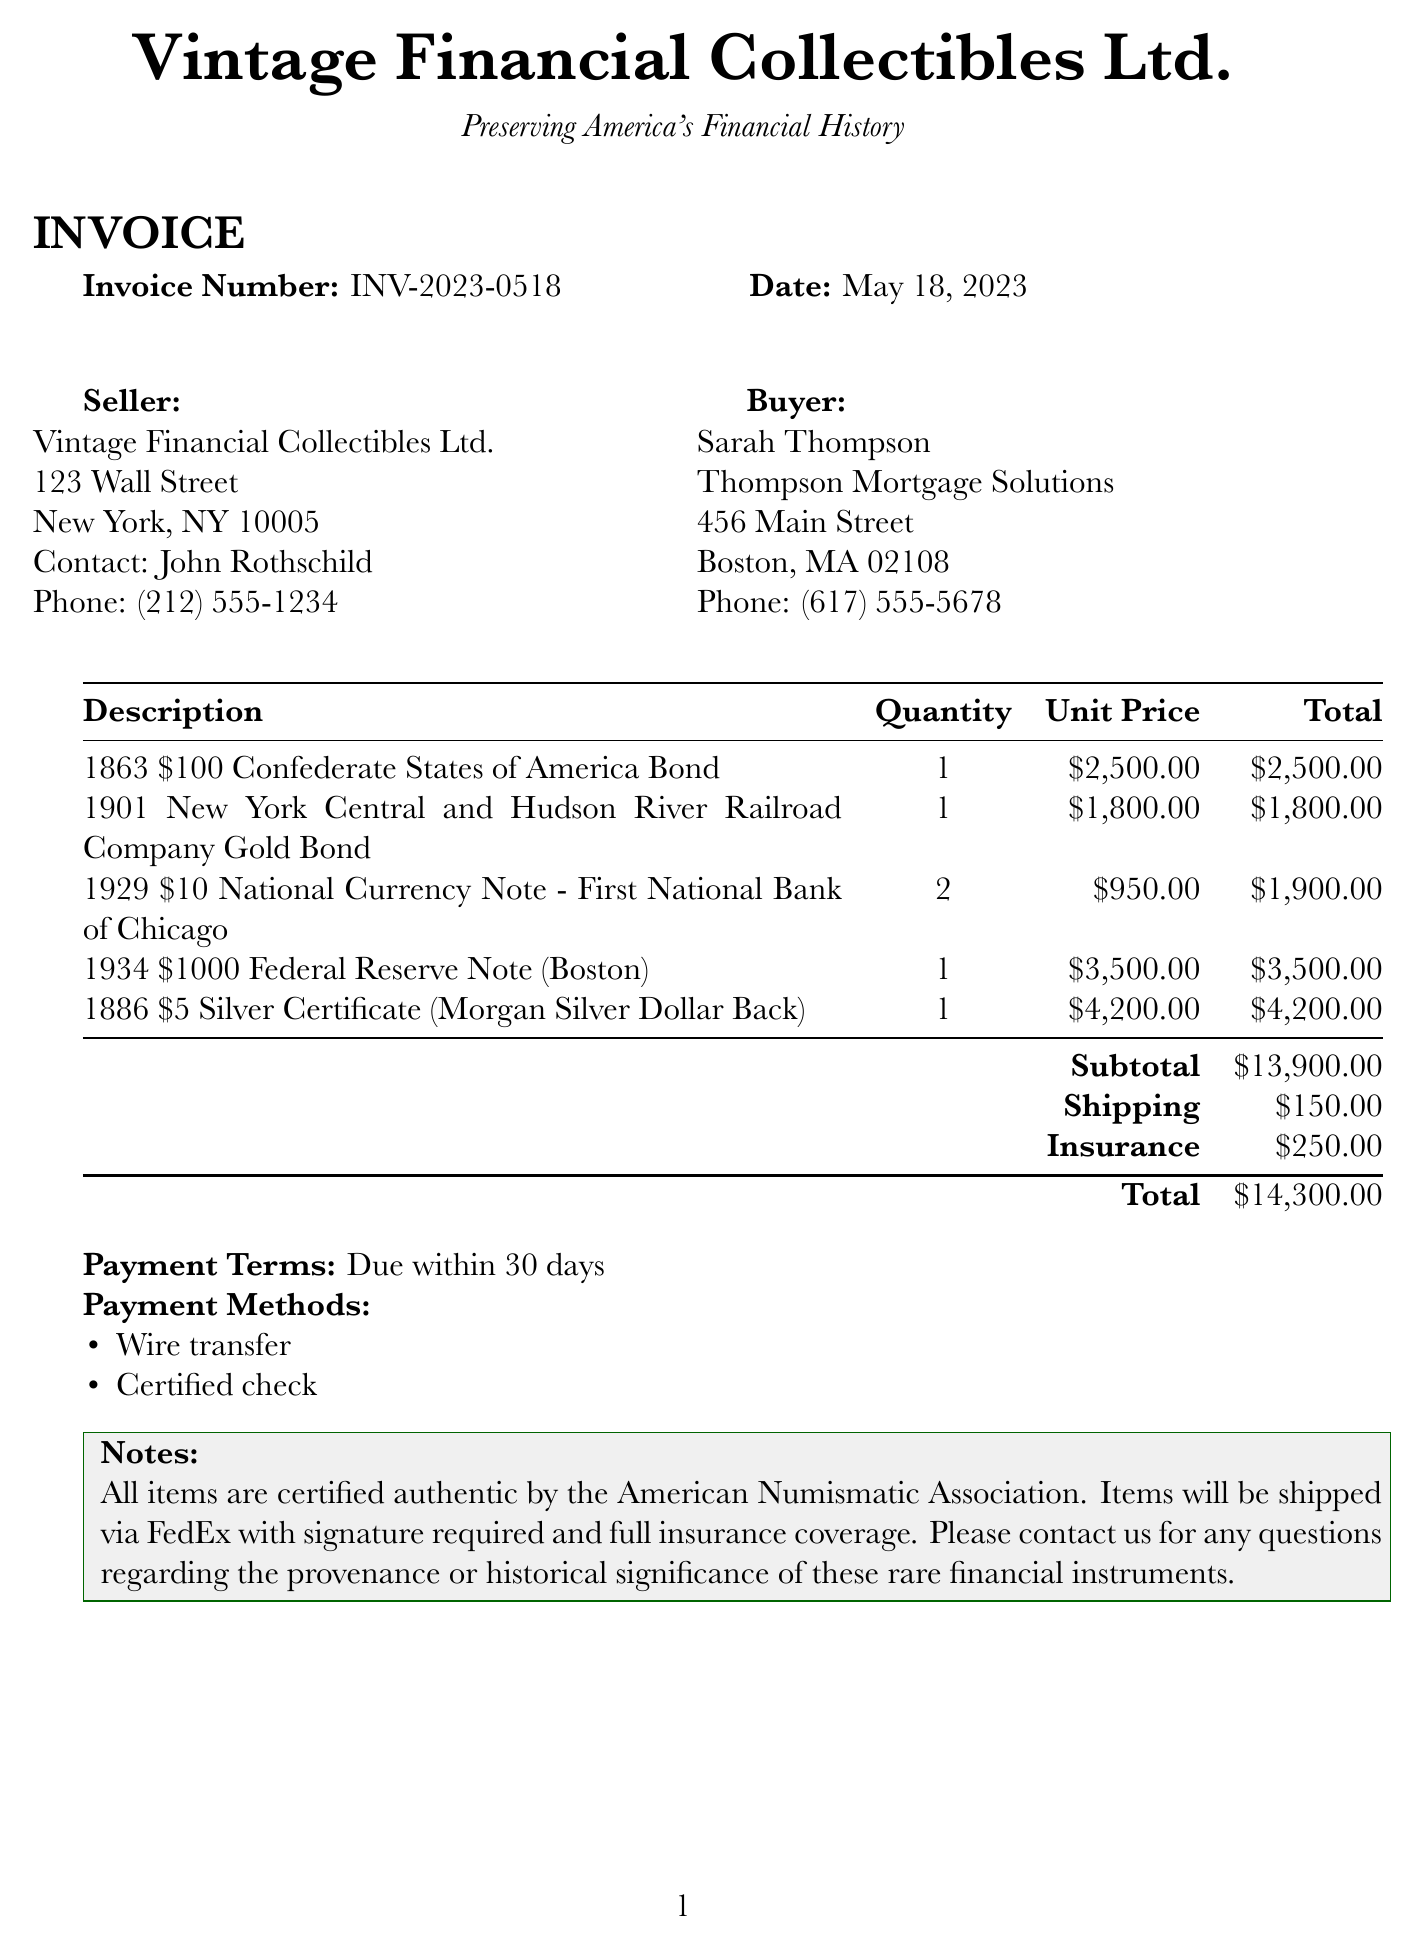What is the invoice number? The invoice number is a unique identifier for this transaction in the document.
Answer: INV-2023-0518 Who is the seller? The seller is the entity providing the vintage financial instruments in this transaction.
Answer: Vintage Financial Collectibles Ltd What is the total amount due? The total amount due is the sum of the subtotal, shipping, and insurance costs listed in the document.
Answer: $14,300.00 How many items were purchased in total? The total quantity of items purchased can be found by summing the quantities of each listed item.
Answer: 5 What is the buyer's company name? The company name identifies the buyer's business entity involved in this transaction.
Answer: Thompson Mortgage Solutions What are the payment methods accepted? The payment methods indicate how the buyer can settle the invoice according to the document.
Answer: Wire transfer, Certified check What is the date of the invoice? The date represents when the invoice was issued and can be found at the top of the document.
Answer: May 18, 2023 What is the subtotal of the invoice? The subtotal is the sum of all item totals before any additional charges are applied, as stated in the document.
Answer: $13,900.00 What shipping method will be used? The shipping method refers to how the items will be transported to the buyer and is mentioned in the notes section.
Answer: FedEx 